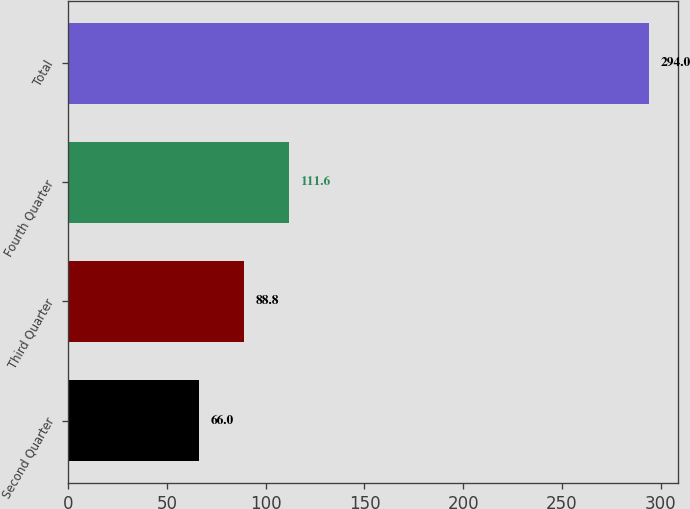<chart> <loc_0><loc_0><loc_500><loc_500><bar_chart><fcel>Second Quarter<fcel>Third Quarter<fcel>Fourth Quarter<fcel>Total<nl><fcel>66<fcel>88.8<fcel>111.6<fcel>294<nl></chart> 